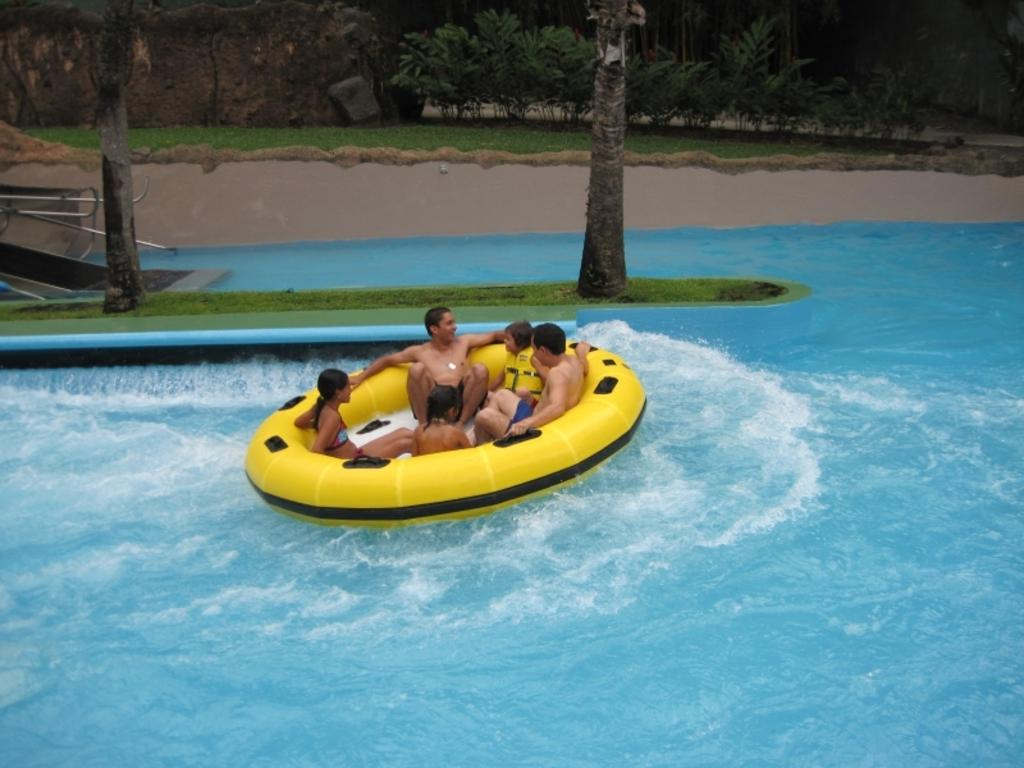What are the people doing in the image? The people are in a water tube in the image. Where is the water tube located? The water tube is on water. What can be seen in the background of the image? There are trees and some unspecified objects in the background of the image. What type of print can be seen on the alley in the image? There is no alley or print present in the image; it features people in a water tube on water with trees and unspecified objects in the background. 